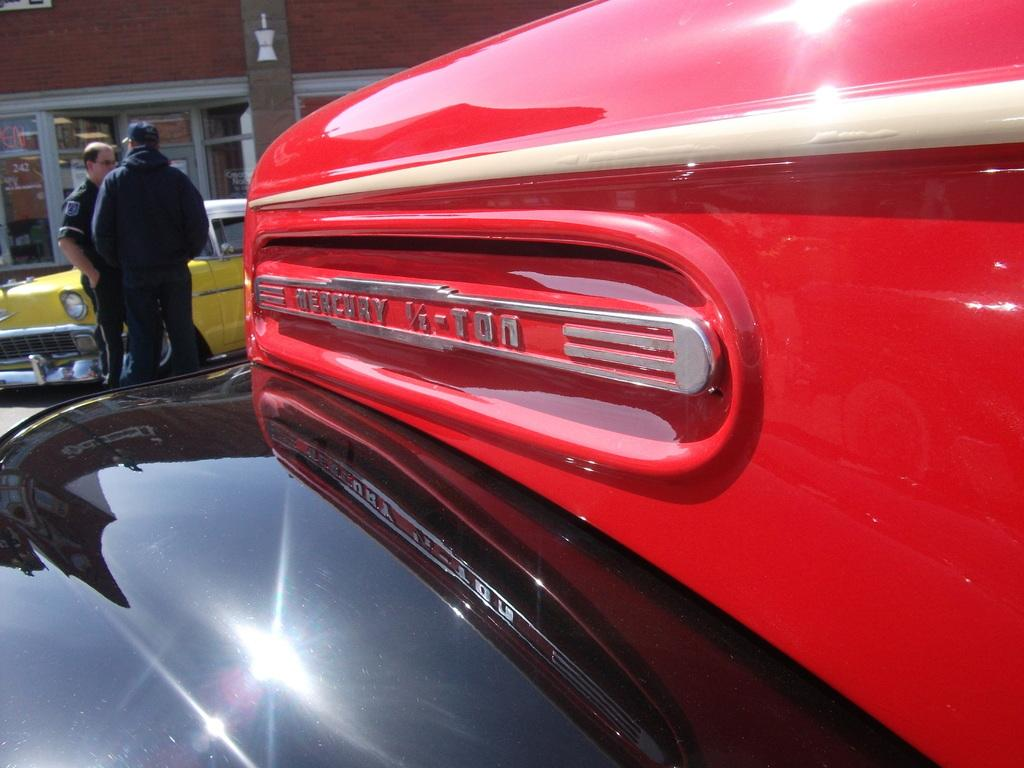<image>
Create a compact narrative representing the image presented. Two men are talking by a red and black old-fashioned truck that says Mercury 1/2-Ton. 